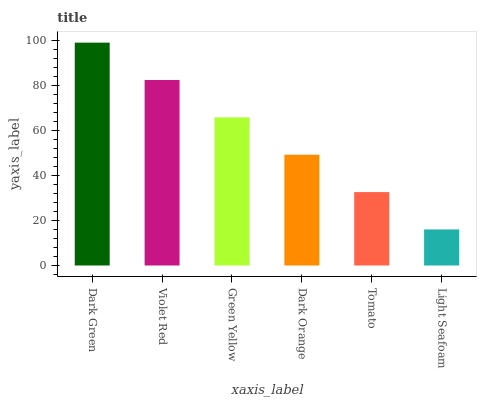Is Violet Red the minimum?
Answer yes or no. No. Is Violet Red the maximum?
Answer yes or no. No. Is Dark Green greater than Violet Red?
Answer yes or no. Yes. Is Violet Red less than Dark Green?
Answer yes or no. Yes. Is Violet Red greater than Dark Green?
Answer yes or no. No. Is Dark Green less than Violet Red?
Answer yes or no. No. Is Green Yellow the high median?
Answer yes or no. Yes. Is Dark Orange the low median?
Answer yes or no. Yes. Is Violet Red the high median?
Answer yes or no. No. Is Tomato the low median?
Answer yes or no. No. 